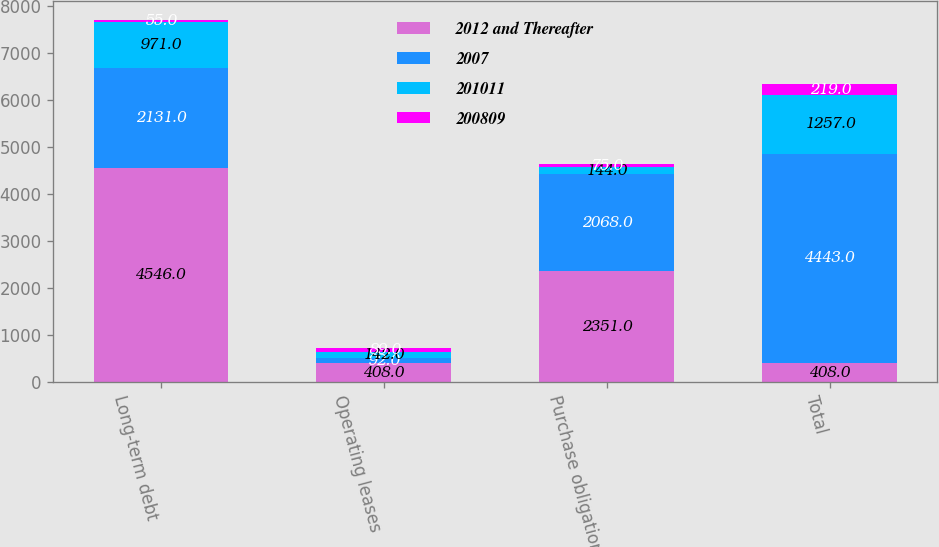Convert chart to OTSL. <chart><loc_0><loc_0><loc_500><loc_500><stacked_bar_chart><ecel><fcel>Long-term debt<fcel>Operating leases<fcel>Purchase obligations<fcel>Total<nl><fcel>2012 and Thereafter<fcel>4546<fcel>408<fcel>2351<fcel>408<nl><fcel>2007<fcel>2131<fcel>92<fcel>2068<fcel>4443<nl><fcel>201011<fcel>971<fcel>142<fcel>144<fcel>1257<nl><fcel>200809<fcel>55<fcel>89<fcel>75<fcel>219<nl></chart> 